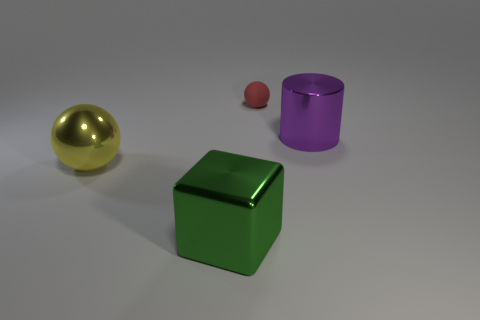Is there anything else that is the same material as the red thing?
Ensure brevity in your answer.  No. Are there any red rubber objects that have the same shape as the yellow metallic object?
Ensure brevity in your answer.  Yes. There is a object that is in front of the ball that is in front of the red sphere; what is it made of?
Your answer should be very brief. Metal. The tiny thing is what shape?
Offer a very short reply. Sphere. Are there an equal number of big spheres in front of the yellow object and big purple shiny cylinders that are behind the tiny red matte object?
Your response must be concise. Yes. Do the big metallic thing right of the metallic block and the ball to the left of the green metal block have the same color?
Offer a very short reply. No. Is the number of purple cylinders to the left of the large green shiny cube greater than the number of large balls?
Your answer should be compact. No. What is the shape of the large yellow thing that is the same material as the purple cylinder?
Your answer should be compact. Sphere. There is a metallic thing that is right of the matte sphere; is its size the same as the metallic cube?
Keep it short and to the point. Yes. There is a big thing in front of the metallic object to the left of the large green metallic object; what shape is it?
Provide a short and direct response. Cube. 